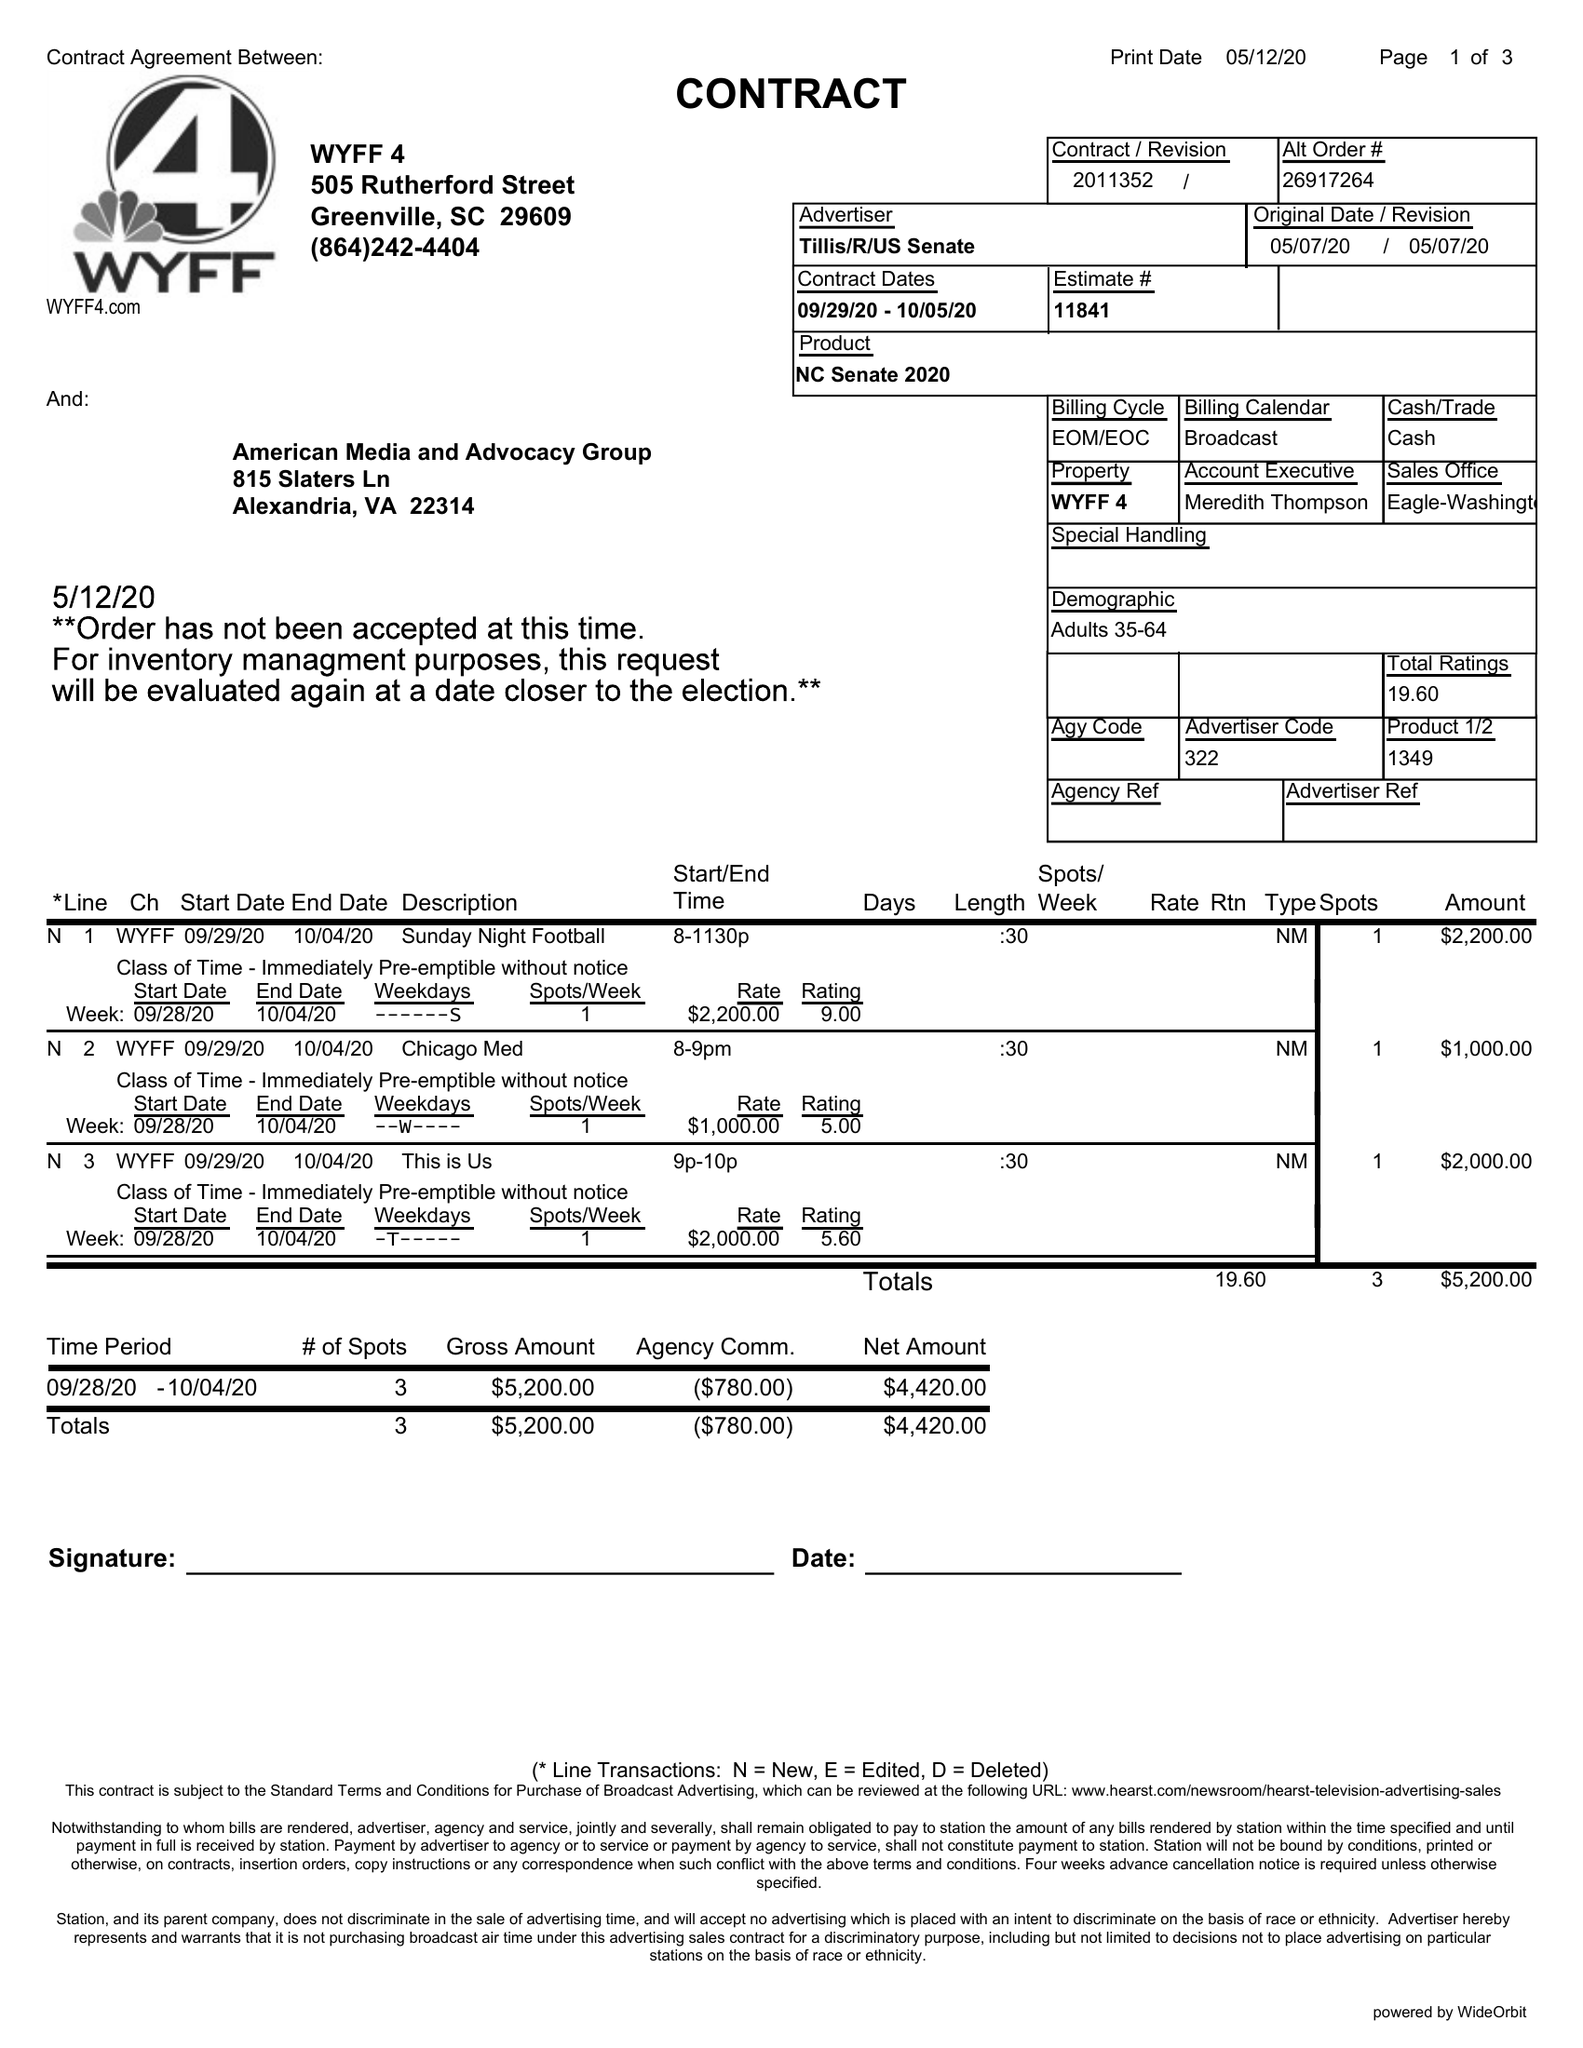What is the value for the gross_amount?
Answer the question using a single word or phrase. 5200.00 